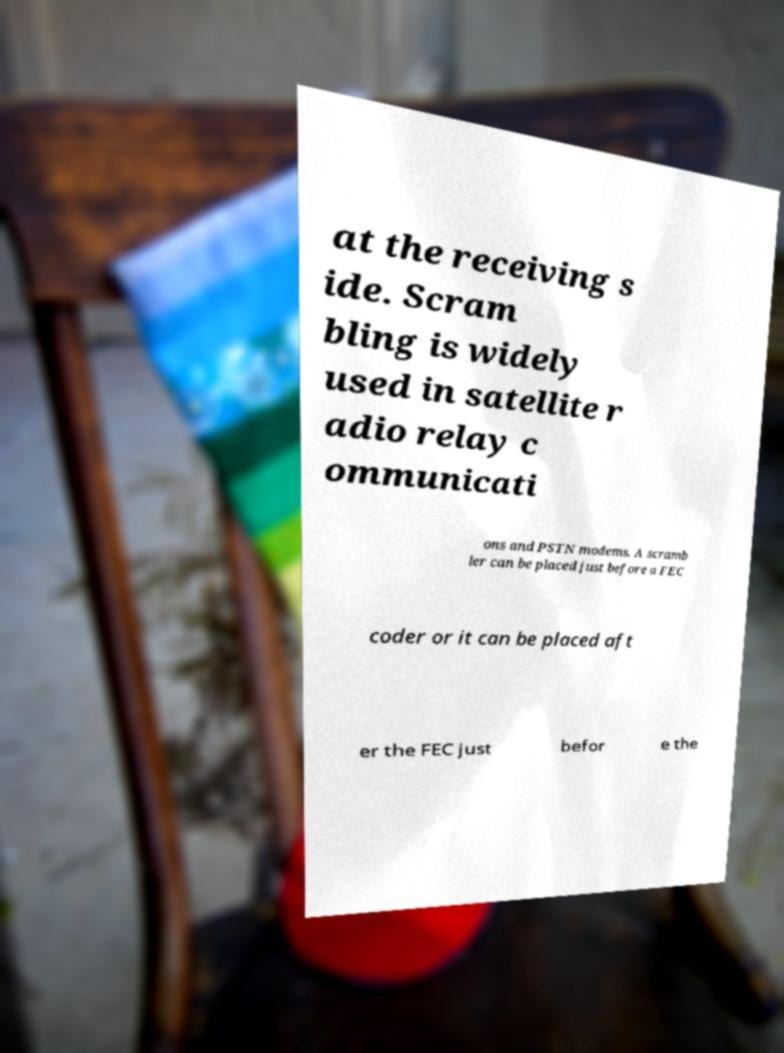Could you extract and type out the text from this image? at the receiving s ide. Scram bling is widely used in satellite r adio relay c ommunicati ons and PSTN modems. A scramb ler can be placed just before a FEC coder or it can be placed aft er the FEC just befor e the 